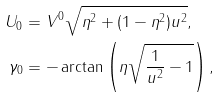Convert formula to latex. <formula><loc_0><loc_0><loc_500><loc_500>U _ { 0 } & = V ^ { 0 } \sqrt { \eta ^ { 2 } + ( 1 - \eta ^ { 2 } ) u ^ { 2 } } , \\ \gamma _ { 0 } & = - \arctan \left ( \eta \sqrt { \frac { 1 } { u ^ { 2 } } - 1 } \right ) ,</formula> 